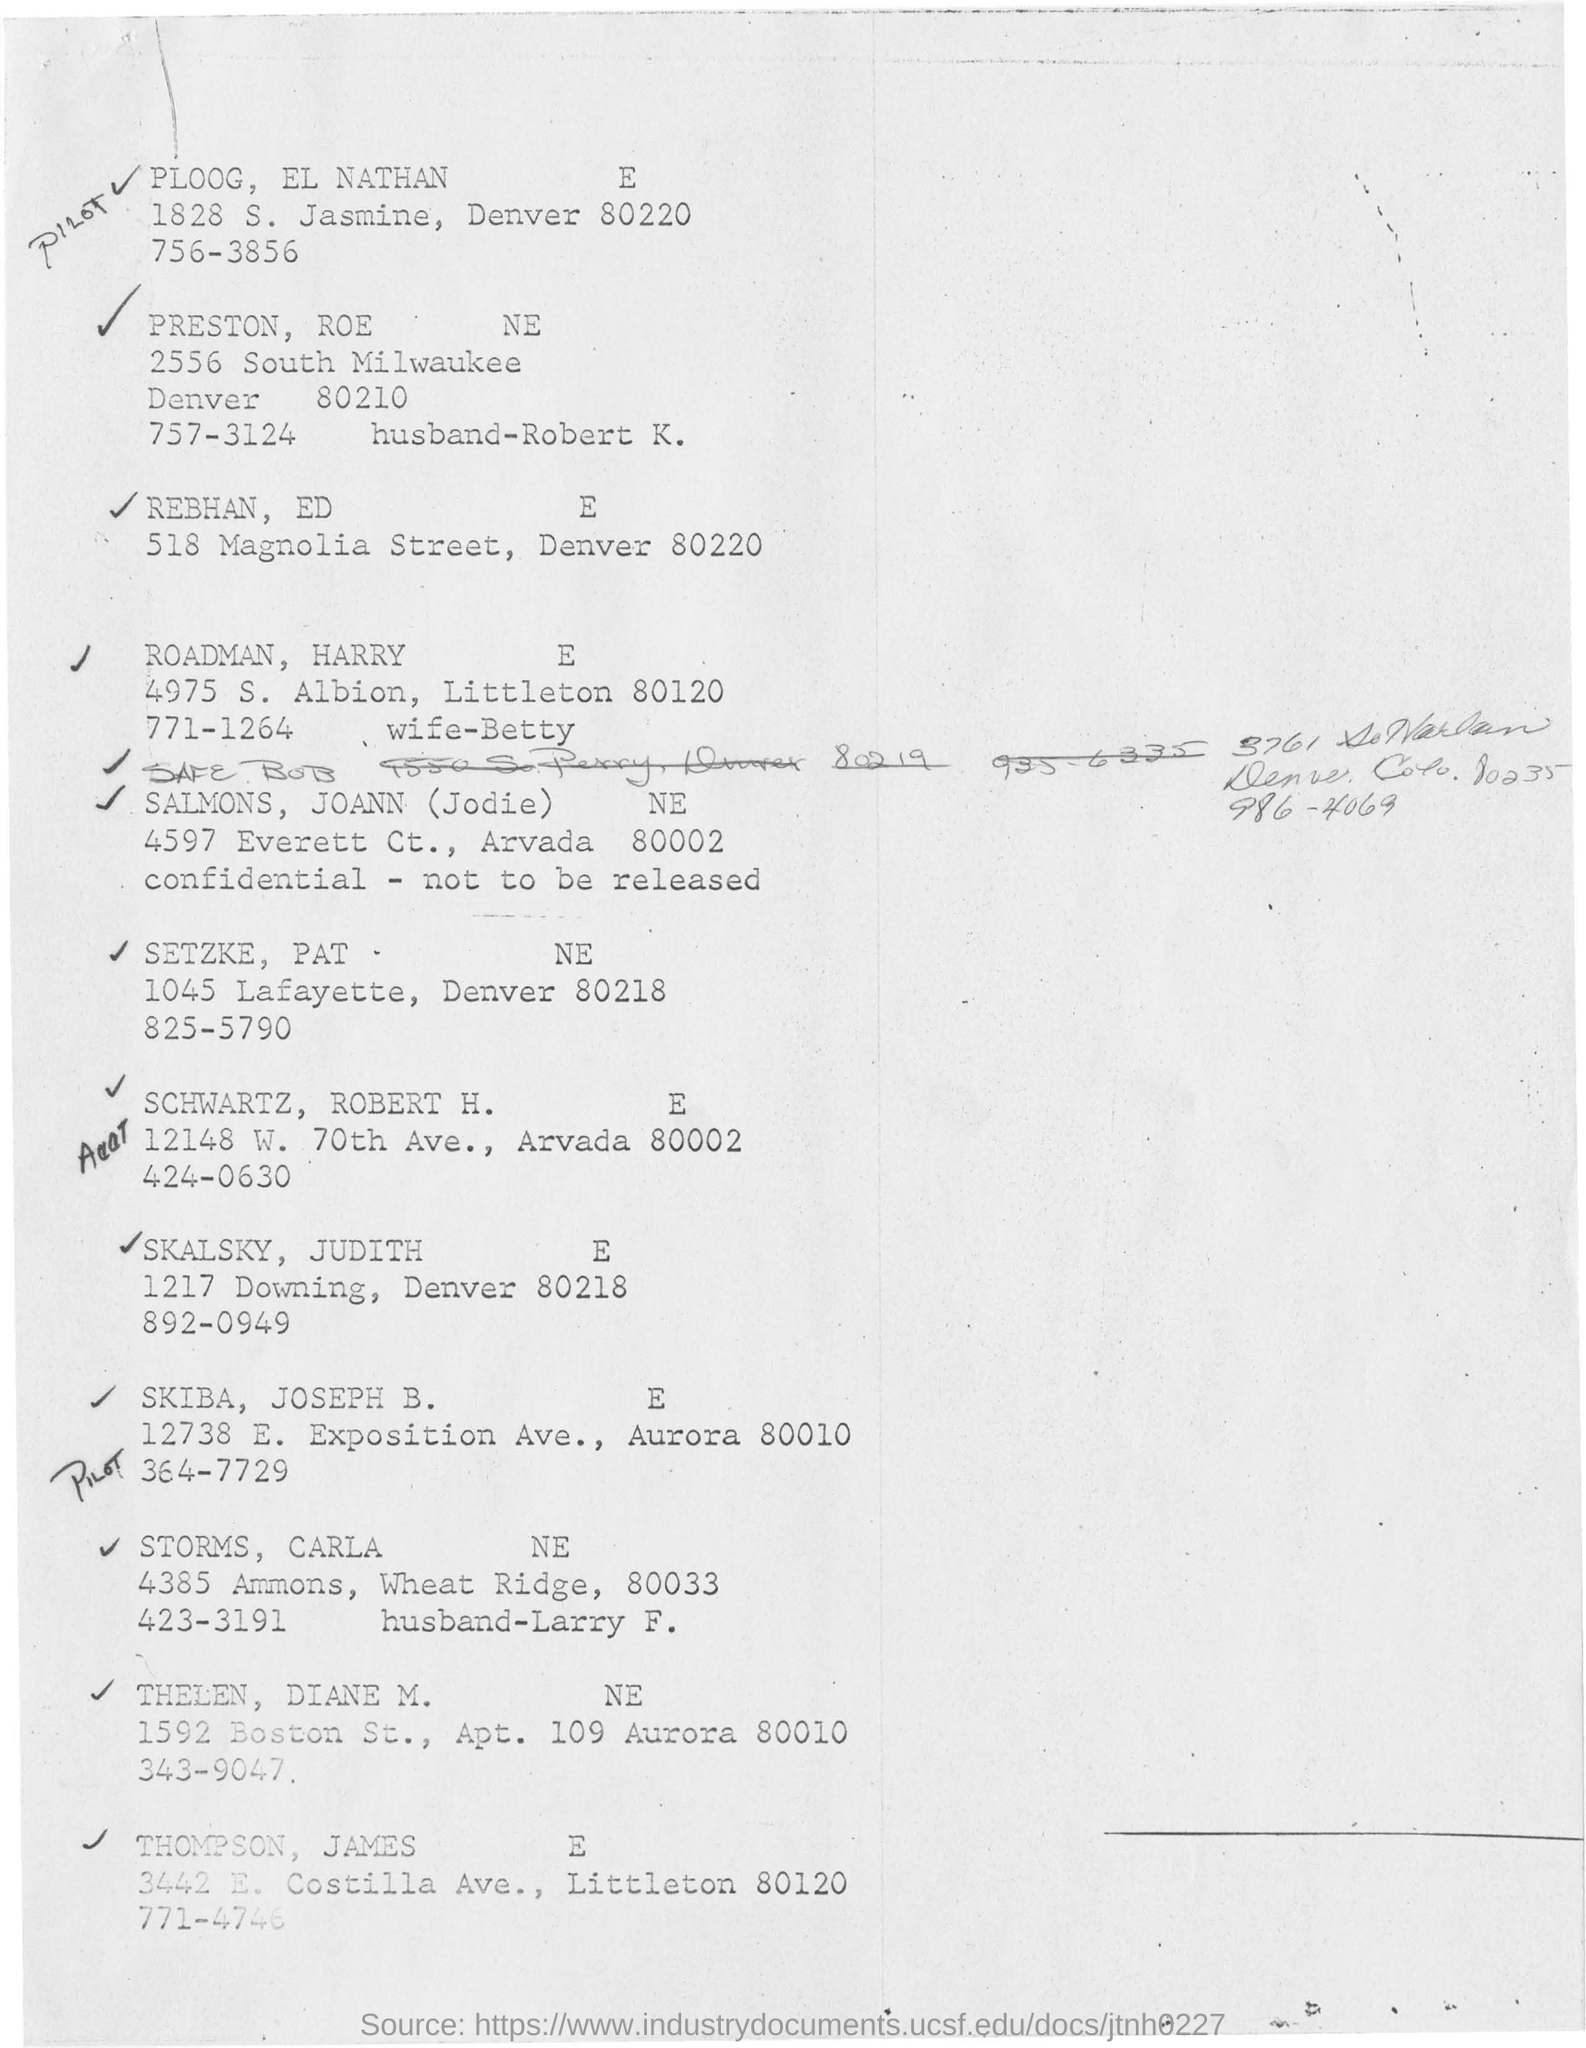Give some essential details in this illustration. The handwritten word at the top of the document is 'PILOT.' The first name in the list is PLOOG, followed by EL NATHAN. The address listed under the name of REBHAN, ED is 518 Magnolia Street in Denver, with a zip code of 80220. The surname mentioned as the second to last is THELEN, with the person being DIANE M... 